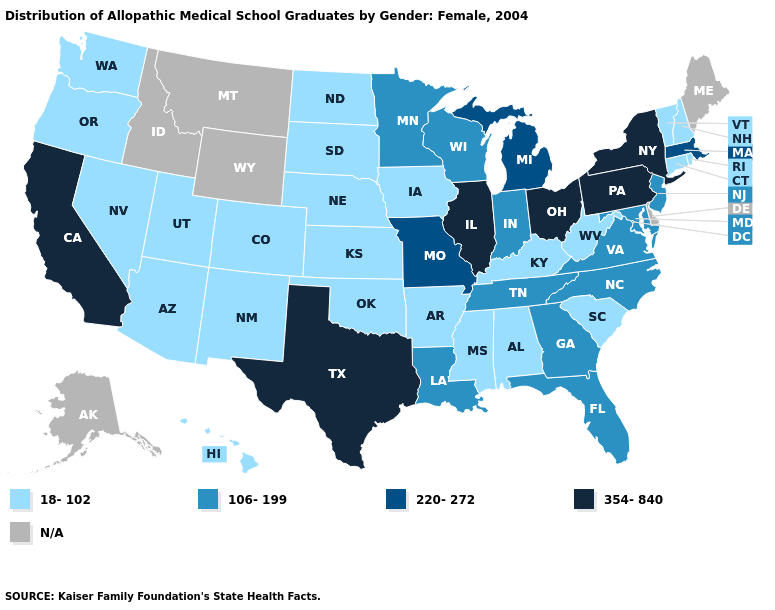Does the first symbol in the legend represent the smallest category?
Be succinct. Yes. What is the highest value in the USA?
Write a very short answer. 354-840. Name the states that have a value in the range 106-199?
Answer briefly. Florida, Georgia, Indiana, Louisiana, Maryland, Minnesota, New Jersey, North Carolina, Tennessee, Virginia, Wisconsin. Name the states that have a value in the range 354-840?
Answer briefly. California, Illinois, New York, Ohio, Pennsylvania, Texas. What is the value of Louisiana?
Short answer required. 106-199. What is the value of Connecticut?
Quick response, please. 18-102. What is the value of Washington?
Be succinct. 18-102. What is the value of Delaware?
Be succinct. N/A. What is the value of Virginia?
Answer briefly. 106-199. Name the states that have a value in the range 18-102?
Be succinct. Alabama, Arizona, Arkansas, Colorado, Connecticut, Hawaii, Iowa, Kansas, Kentucky, Mississippi, Nebraska, Nevada, New Hampshire, New Mexico, North Dakota, Oklahoma, Oregon, Rhode Island, South Carolina, South Dakota, Utah, Vermont, Washington, West Virginia. Which states have the lowest value in the USA?
Keep it brief. Alabama, Arizona, Arkansas, Colorado, Connecticut, Hawaii, Iowa, Kansas, Kentucky, Mississippi, Nebraska, Nevada, New Hampshire, New Mexico, North Dakota, Oklahoma, Oregon, Rhode Island, South Carolina, South Dakota, Utah, Vermont, Washington, West Virginia. Among the states that border Maine , which have the lowest value?
Be succinct. New Hampshire. What is the highest value in the MidWest ?
Quick response, please. 354-840. What is the lowest value in states that border Wyoming?
Answer briefly. 18-102. 